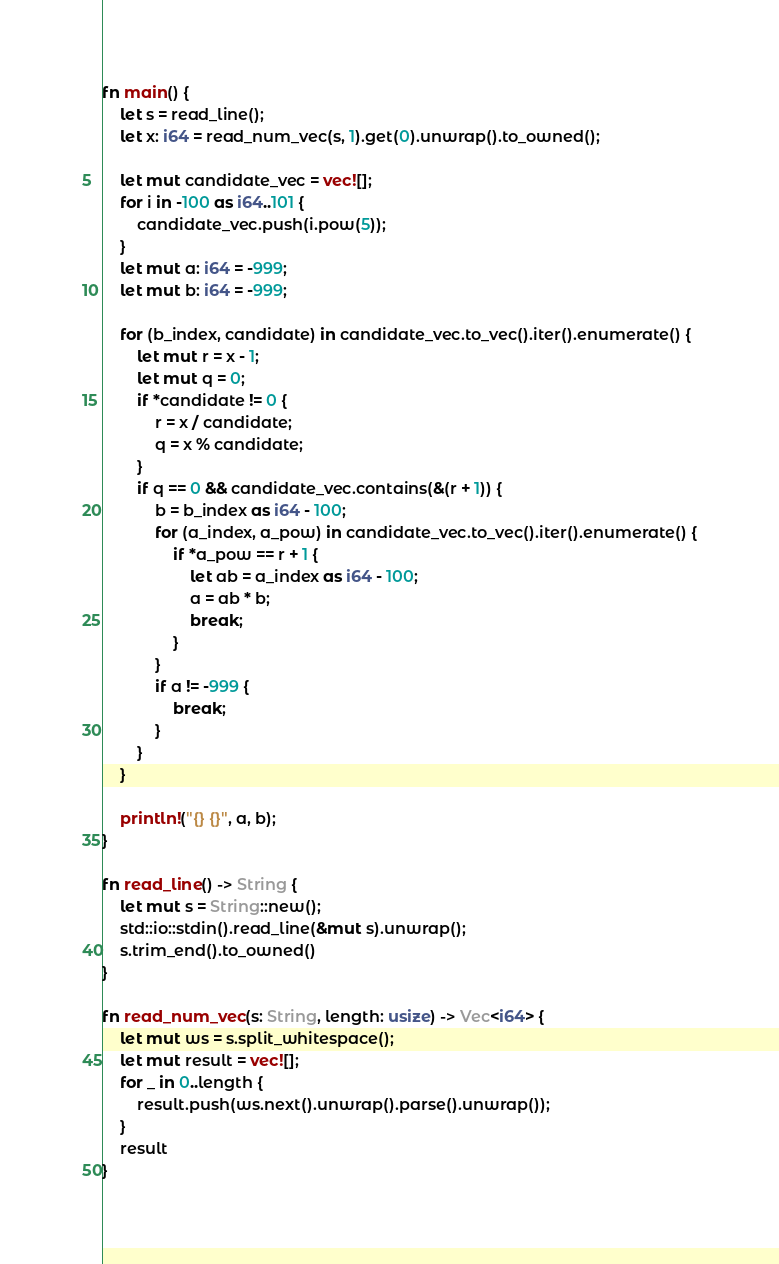<code> <loc_0><loc_0><loc_500><loc_500><_Rust_>fn main() {
    let s = read_line();
    let x: i64 = read_num_vec(s, 1).get(0).unwrap().to_owned();

    let mut candidate_vec = vec![];
    for i in -100 as i64..101 {
        candidate_vec.push(i.pow(5));
    }
    let mut a: i64 = -999;
    let mut b: i64 = -999;

    for (b_index, candidate) in candidate_vec.to_vec().iter().enumerate() {
        let mut r = x - 1;
        let mut q = 0;
        if *candidate != 0 {
            r = x / candidate;
            q = x % candidate;
        }
        if q == 0 && candidate_vec.contains(&(r + 1)) {
            b = b_index as i64 - 100;
            for (a_index, a_pow) in candidate_vec.to_vec().iter().enumerate() {
                if *a_pow == r + 1 {
                    let ab = a_index as i64 - 100;
                    a = ab * b;
                    break;
                }
            }
            if a != -999 {
                break;
            }
        }
    }

    println!("{} {}", a, b);
}

fn read_line() -> String {
    let mut s = String::new();
    std::io::stdin().read_line(&mut s).unwrap();
    s.trim_end().to_owned()
}

fn read_num_vec(s: String, length: usize) -> Vec<i64> {
    let mut ws = s.split_whitespace();
    let mut result = vec![];
    for _ in 0..length {
        result.push(ws.next().unwrap().parse().unwrap());
    }
    result
}
</code> 